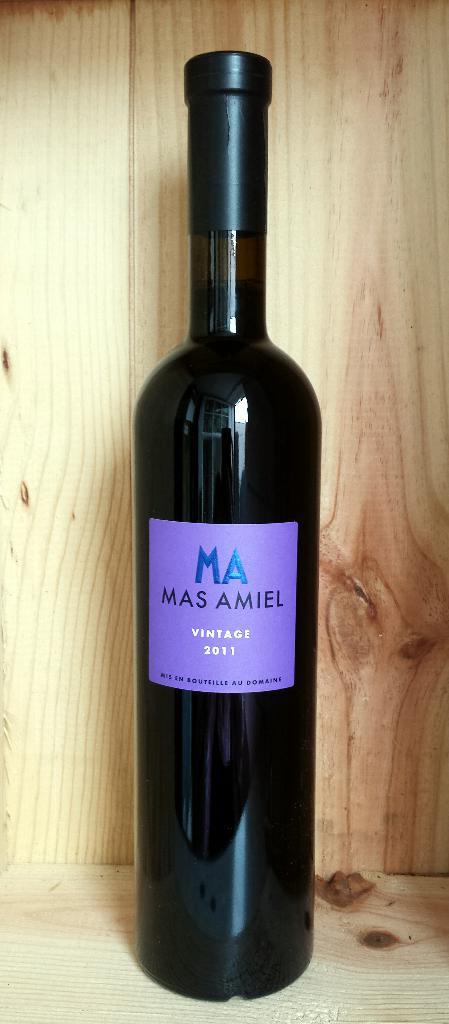What 2 letters are printed in blue on the bottle?
Your response must be concise. Ma. 